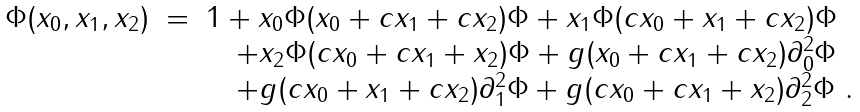Convert formula to latex. <formula><loc_0><loc_0><loc_500><loc_500>\begin{array} { r c l } \Phi ( x _ { 0 } , x _ { 1 } , x _ { 2 } ) & = & 1 + x _ { 0 } \Phi ( x _ { 0 } + c x _ { 1 } + c x _ { 2 } ) \Phi + x _ { 1 } \Phi ( c x _ { 0 } + x _ { 1 } + c x _ { 2 } ) \Phi \\ & & \quad + x _ { 2 } \Phi ( c x _ { 0 } + c x _ { 1 } + x _ { 2 } ) \Phi + g ( x _ { 0 } + c x _ { 1 } + c x _ { 2 } ) \partial ^ { 2 } _ { 0 } \Phi \\ & & \quad + g ( c x _ { 0 } + x _ { 1 } + c x _ { 2 } ) \partial ^ { 2 } _ { 1 } \Phi + g ( c x _ { 0 } + c x _ { 1 } + x _ { 2 } ) \partial ^ { 2 } _ { 2 } \Phi \ . \end{array} \label l { e q \colon 3 s p g e n }</formula> 